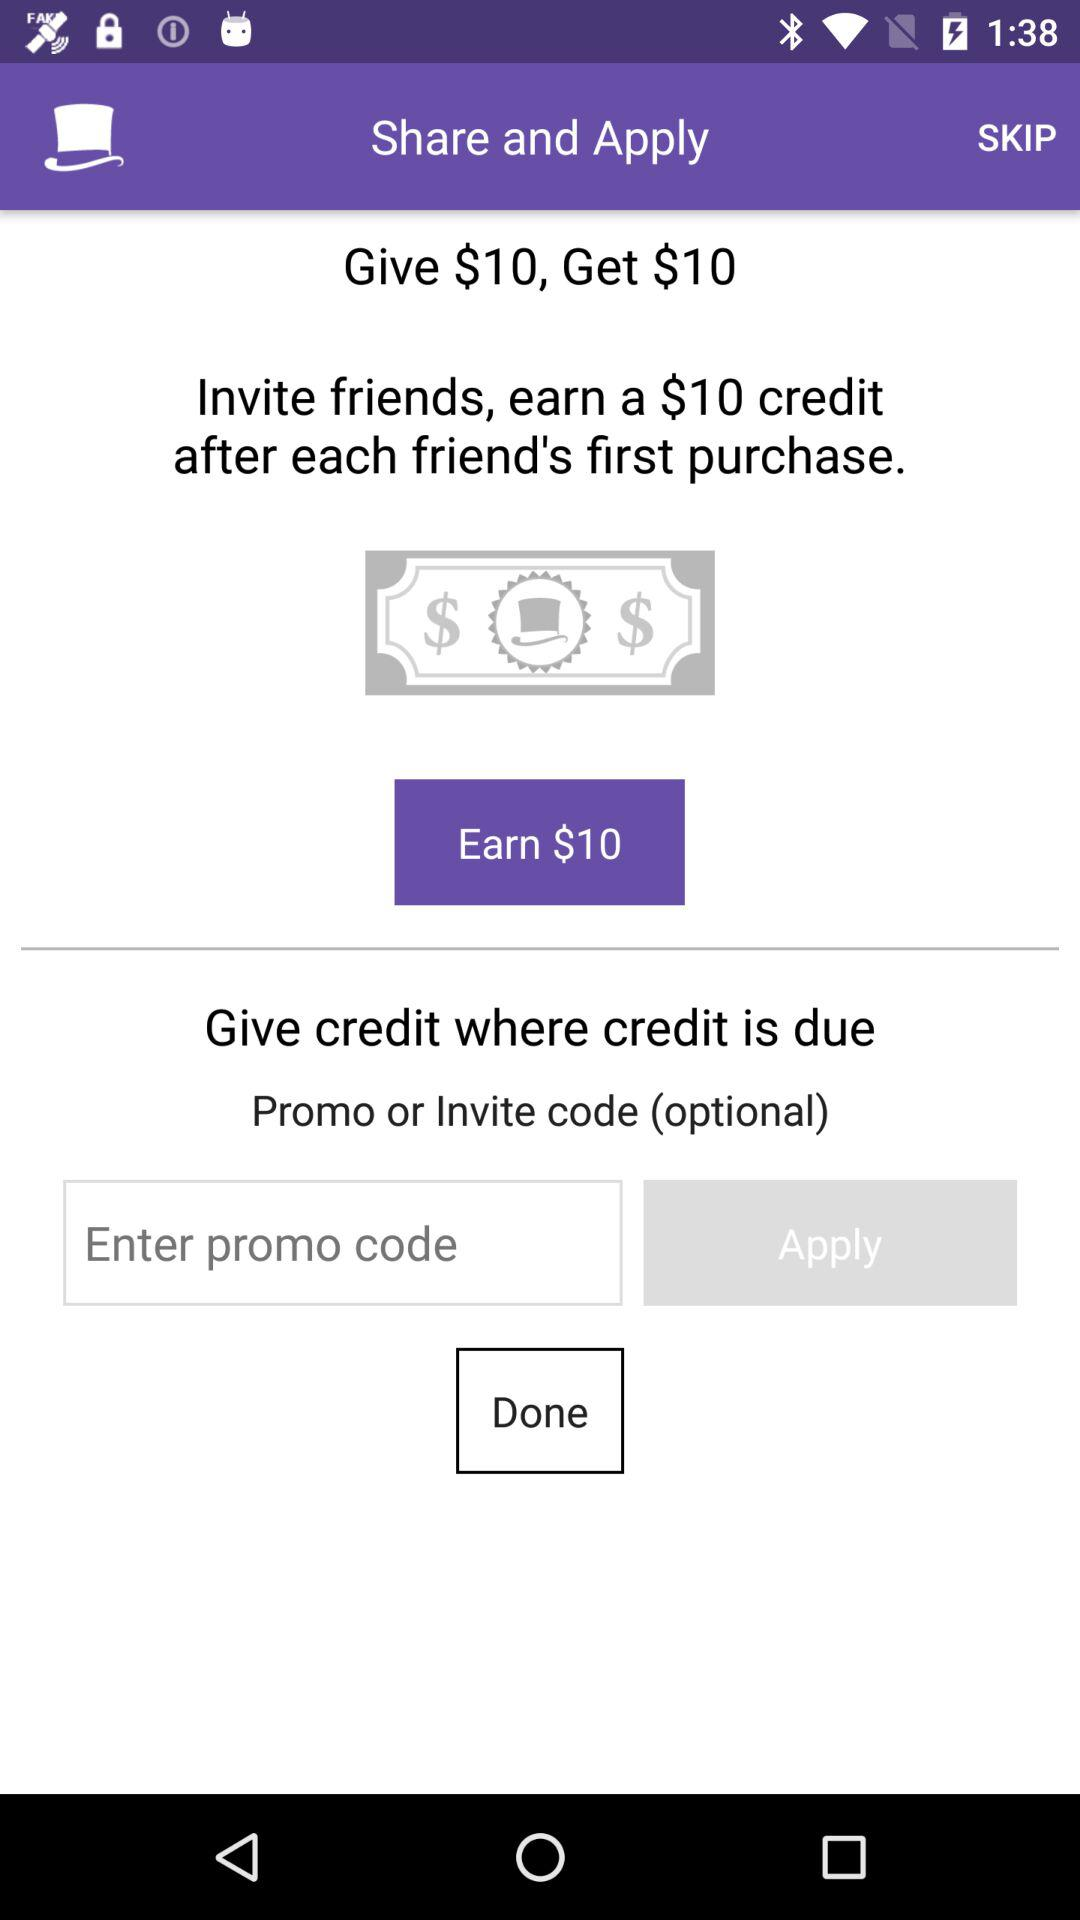How much amount will we get? You will get $10. 